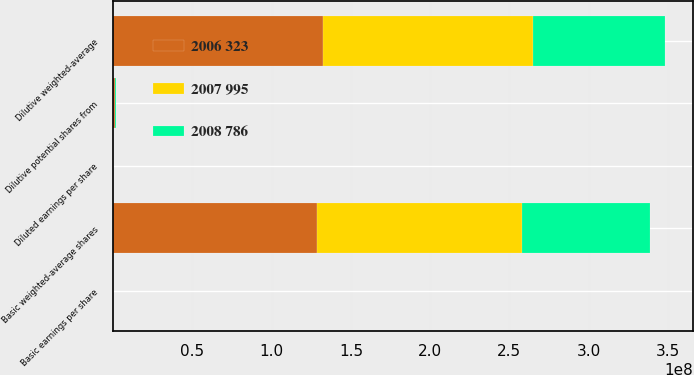Convert chart to OTSL. <chart><loc_0><loc_0><loc_500><loc_500><stacked_bar_chart><ecel><fcel>Basic weighted-average shares<fcel>Dilutive potential shares from<fcel>Dilutive weighted-average<fcel>Basic earnings per share<fcel>Diluted earnings per share<nl><fcel>2007 995<fcel>1.29543e+08<fcel>254284<fcel>1.32996e+08<fcel>6.07<fcel>5.91<nl><fcel>2006 323<fcel>1.28489e+08<fcel>1.03379e+06<fcel>1.32089e+08<fcel>7.75<fcel>7.53<nl><fcel>2008 786<fcel>8.06382e+07<fcel>513088<fcel>8.33584e+07<fcel>4<fcel>3.87<nl></chart> 